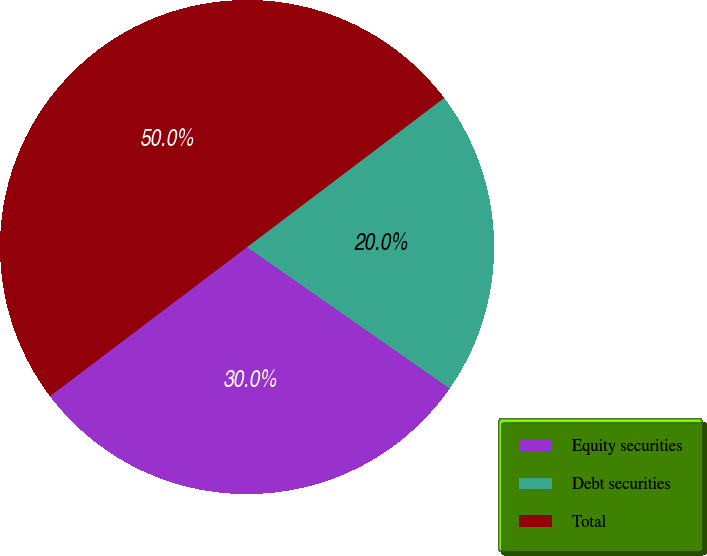<chart> <loc_0><loc_0><loc_500><loc_500><pie_chart><fcel>Equity securities<fcel>Debt securities<fcel>Total<nl><fcel>30.0%<fcel>20.0%<fcel>50.0%<nl></chart> 